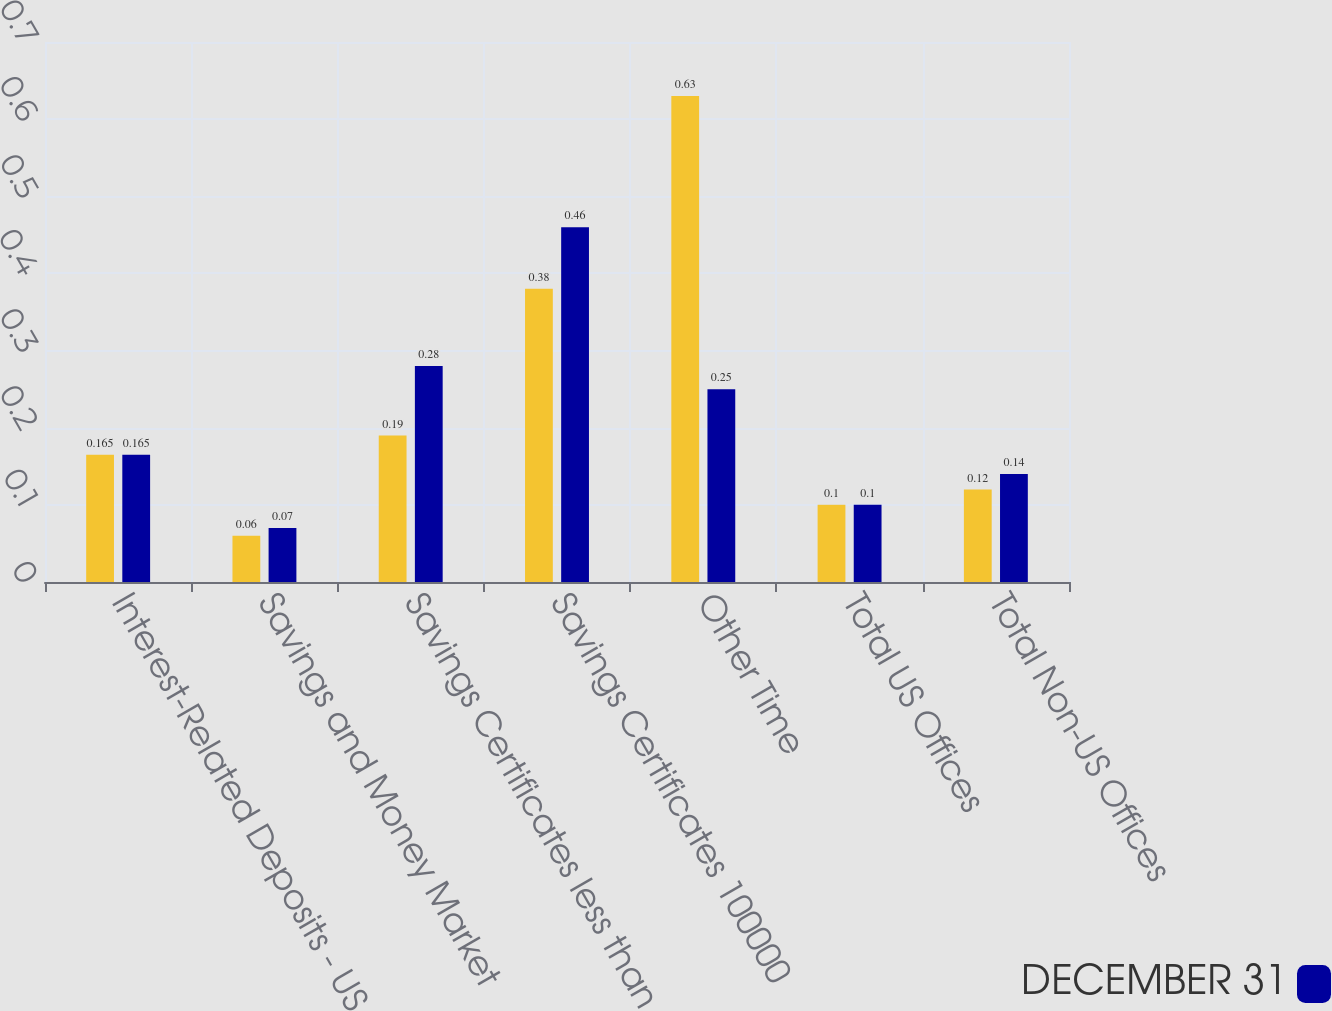Convert chart. <chart><loc_0><loc_0><loc_500><loc_500><stacked_bar_chart><ecel><fcel>Interest-Related Deposits - US<fcel>Savings and Money Market<fcel>Savings Certificates less than<fcel>Savings Certificates 100000<fcel>Other Time<fcel>Total US Offices<fcel>Total Non-US Offices<nl><fcel>nan<fcel>0.165<fcel>0.06<fcel>0.19<fcel>0.38<fcel>0.63<fcel>0.1<fcel>0.12<nl><fcel>DECEMBER 31<fcel>0.165<fcel>0.07<fcel>0.28<fcel>0.46<fcel>0.25<fcel>0.1<fcel>0.14<nl></chart> 